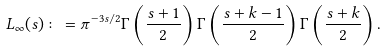<formula> <loc_0><loc_0><loc_500><loc_500>L _ { \infty } ( s ) \colon = \pi ^ { - 3 s / 2 } \Gamma \left ( \frac { s + 1 } { 2 } \right ) \Gamma \left ( \frac { s + k - 1 } { 2 } \right ) \Gamma \left ( \frac { s + k } { 2 } \right ) .</formula> 